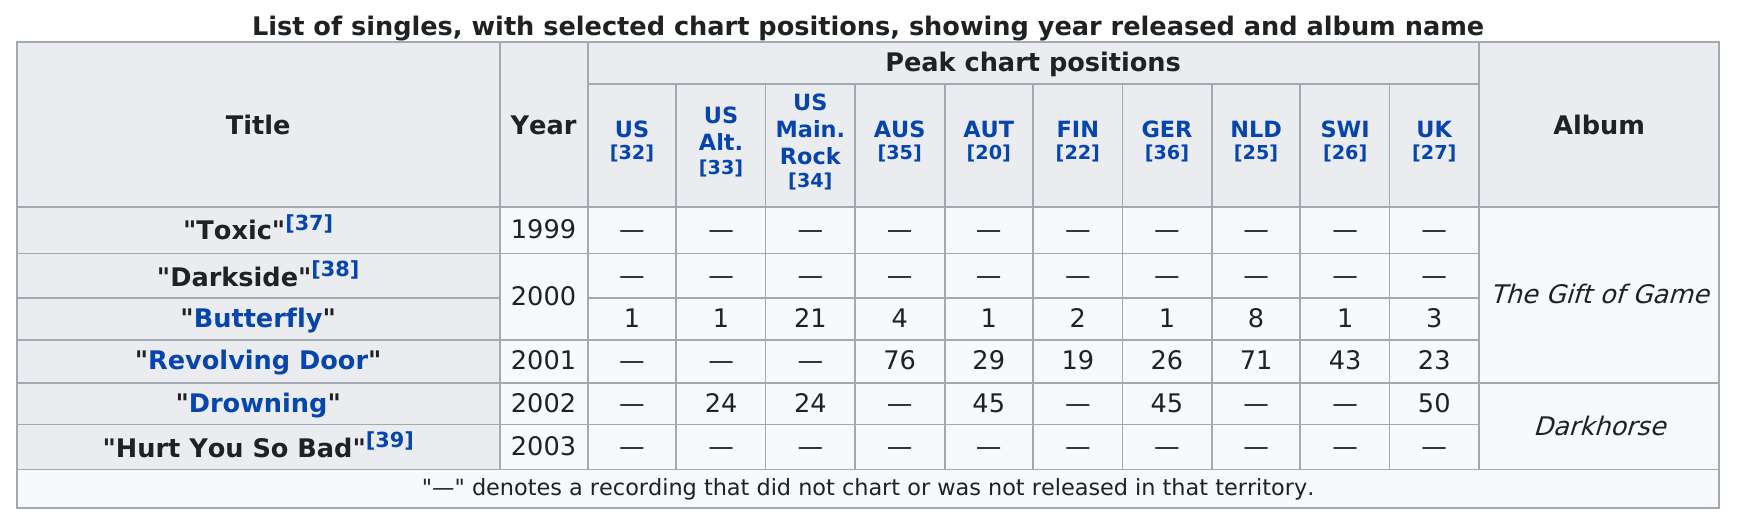List a handful of essential elements in this visual. Revolving Door" peaked at a higher chart position in the UK compared to "Drowning," which peaked at position 27 in the UK. The single "Drowning" was featured on the album "Darkhorse" and was released in 2002. Forty-four singles were created from the album 'The Gift of Game,' including four. There are currently 1 ranked singles in the database with a ranking of 1 under GER? The song titled "Butterfly" is ranked first in both the United States and the United States Alternative charts. 